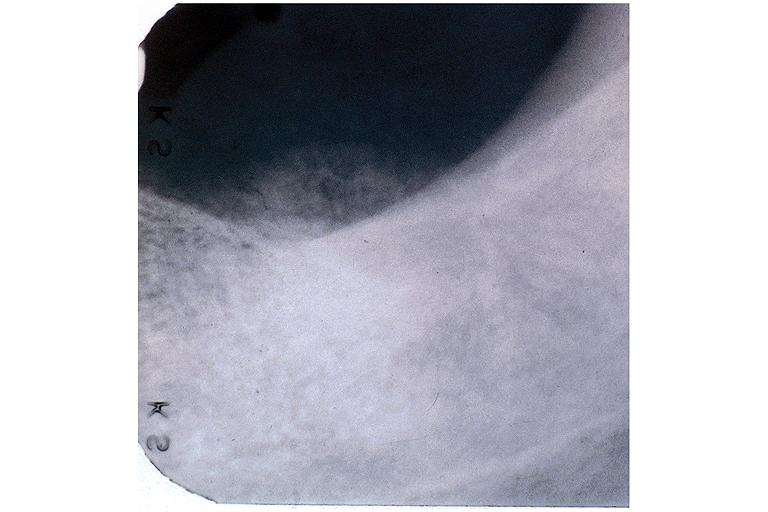what is present?
Answer the question using a single word or phrase. Oral 